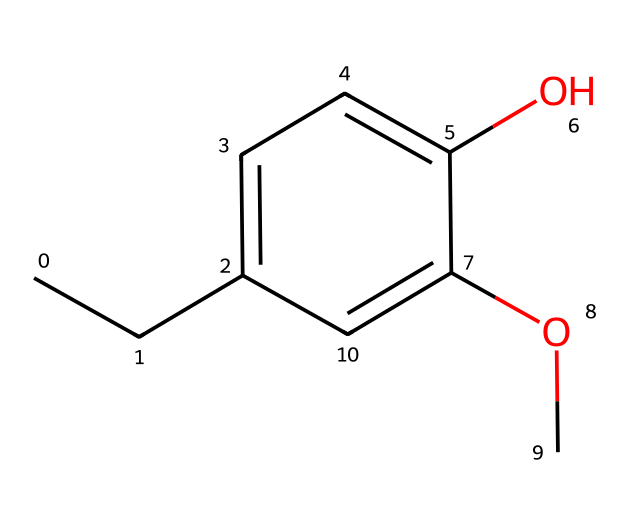What is the molecular formula of eugenol? The molecular formula can be derived from the structural representation by counting each type of atom: there are 10 carbon atoms, 12 hydrogen atoms, and 2 oxygen atoms. Thus, the molecular formula is C10H12O2.
Answer: C10H12O2 How many hydroxyl (OH) groups are present in eugenol? By examining the structure, we can identify the presence of a single hydroxyl group in the aromatic ring. Therefore, there is one OH group.
Answer: 1 What functional group is present in eugenol that contributes to its aromatic properties? The presence of a hydroxyl group (-OH) attached to an aromatic ring significantly influences the compound's aromatic characteristics. This functional group is a typical feature of phenols, increasing its aromaticity.
Answer: hydroxyl group In eugenol, how many double bonds are found in the main chain? The structure indicates that there are two double bonds: one within the aromatic ring and one in the ether linkage. Thus, the total is two double bonds.
Answer: 2 Which part of eugenol contributes to its clove-like aroma? The aromatic ring in the structure, along with the specific arrangement of substituents, is responsible for eugenol's clove-like scent. The conjugation in the aromatic system enhances the aroma profile characteristic of cloves.
Answer: aromatic ring What type of bond links the -O- in the structure of eugenol? The bond connecting the ether oxygen (-O-) to the carbon atoms in eugenol is a single bond, which is typical for ether linkages.
Answer: single bond 